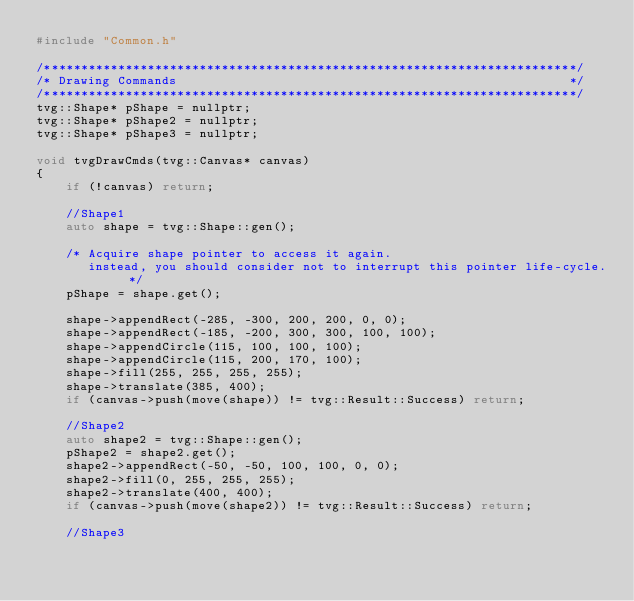<code> <loc_0><loc_0><loc_500><loc_500><_C++_>#include "Common.h"

/************************************************************************/
/* Drawing Commands                                                     */
/************************************************************************/
tvg::Shape* pShape = nullptr;
tvg::Shape* pShape2 = nullptr;
tvg::Shape* pShape3 = nullptr;

void tvgDrawCmds(tvg::Canvas* canvas)
{
    if (!canvas) return;

    //Shape1
    auto shape = tvg::Shape::gen();

    /* Acquire shape pointer to access it again.
       instead, you should consider not to interrupt this pointer life-cycle. */
    pShape = shape.get();

    shape->appendRect(-285, -300, 200, 200, 0, 0);
    shape->appendRect(-185, -200, 300, 300, 100, 100);
    shape->appendCircle(115, 100, 100, 100);
    shape->appendCircle(115, 200, 170, 100);
    shape->fill(255, 255, 255, 255);
    shape->translate(385, 400);
    if (canvas->push(move(shape)) != tvg::Result::Success) return;

    //Shape2
    auto shape2 = tvg::Shape::gen();
    pShape2 = shape2.get();
    shape2->appendRect(-50, -50, 100, 100, 0, 0);
    shape2->fill(0, 255, 255, 255);
    shape2->translate(400, 400);
    if (canvas->push(move(shape2)) != tvg::Result::Success) return;

    //Shape3</code> 